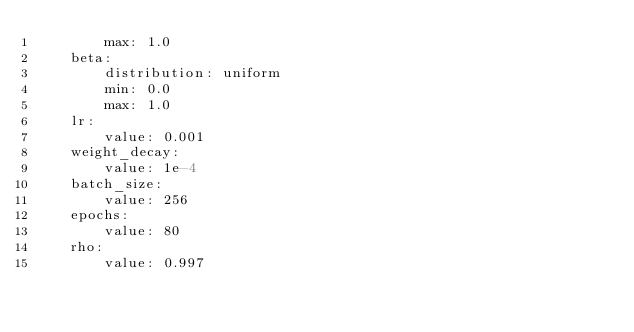Convert code to text. <code><loc_0><loc_0><loc_500><loc_500><_YAML_>        max: 1.0
    beta:
        distribution: uniform
        min: 0.0
        max: 1.0
    lr:
        value: 0.001
    weight_decay:
        value: 1e-4
    batch_size:
        value: 256
    epochs:
        value: 80
    rho:
        value: 0.997
</code> 